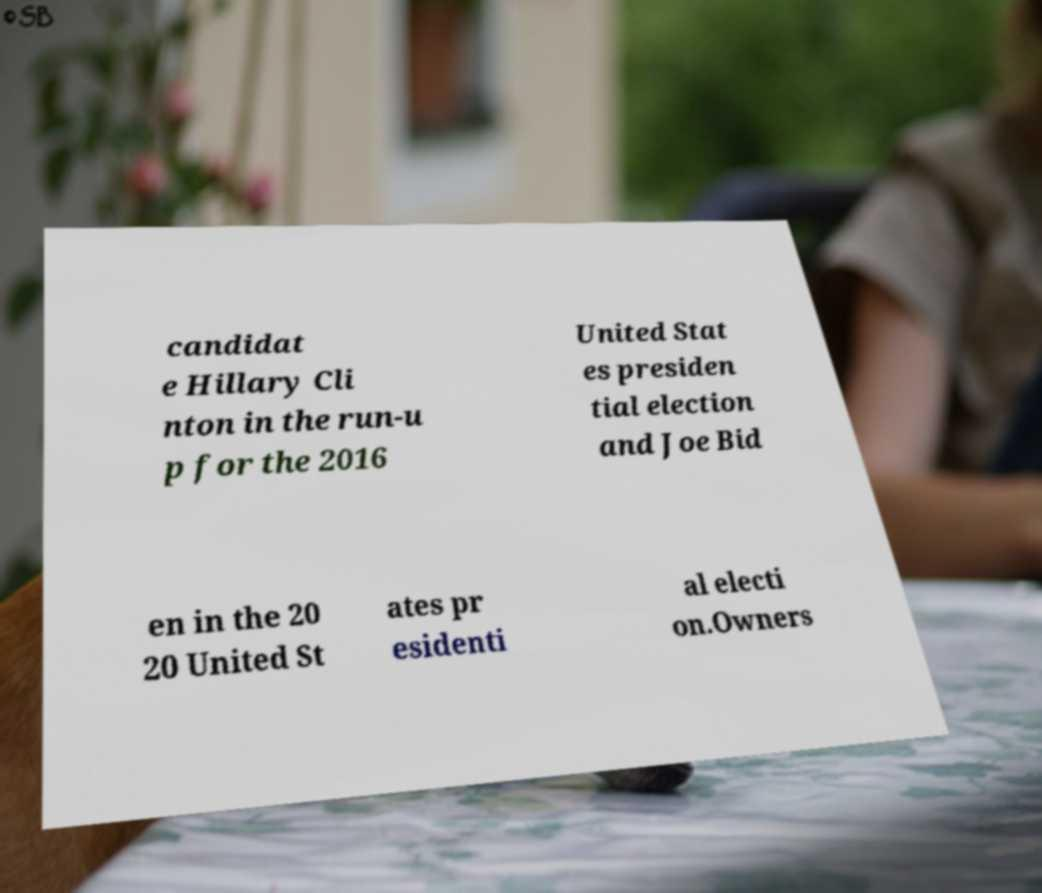Could you assist in decoding the text presented in this image and type it out clearly? candidat e Hillary Cli nton in the run-u p for the 2016 United Stat es presiden tial election and Joe Bid en in the 20 20 United St ates pr esidenti al electi on.Owners 